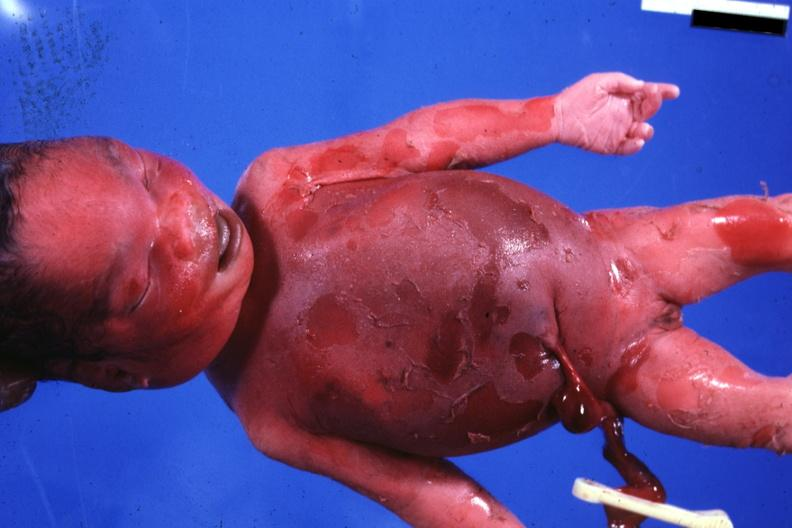does retroperitoneal liposarcoma show typical appearance 980gm?
Answer the question using a single word or phrase. No 